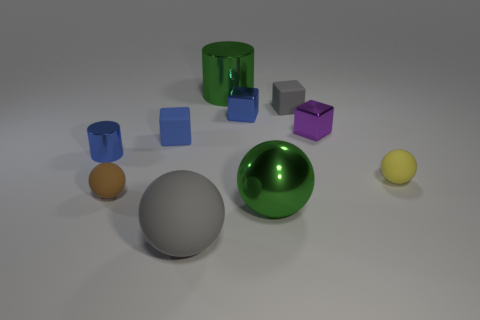How many other objects are the same material as the small gray thing?
Provide a succinct answer. 4. How many shiny objects are purple blocks or small blue cubes?
Offer a very short reply. 2. What is the material of the small cube right of the small rubber cube that is to the right of the gray matte sphere?
Provide a succinct answer. Metal. There is a small thing that is the same color as the big matte ball; what is it made of?
Your answer should be very brief. Rubber. What color is the large metallic ball?
Provide a short and direct response. Green. There is a matte block that is on the left side of the big gray matte thing; is there a blue metal thing that is behind it?
Provide a succinct answer. Yes. What is the material of the tiny brown ball?
Keep it short and to the point. Rubber. Are the small ball that is right of the large shiny cylinder and the tiny sphere that is in front of the yellow sphere made of the same material?
Keep it short and to the point. Yes. Is there any other thing that has the same color as the large rubber thing?
Ensure brevity in your answer.  Yes. What color is the other metal object that is the same shape as the small purple object?
Offer a very short reply. Blue. 